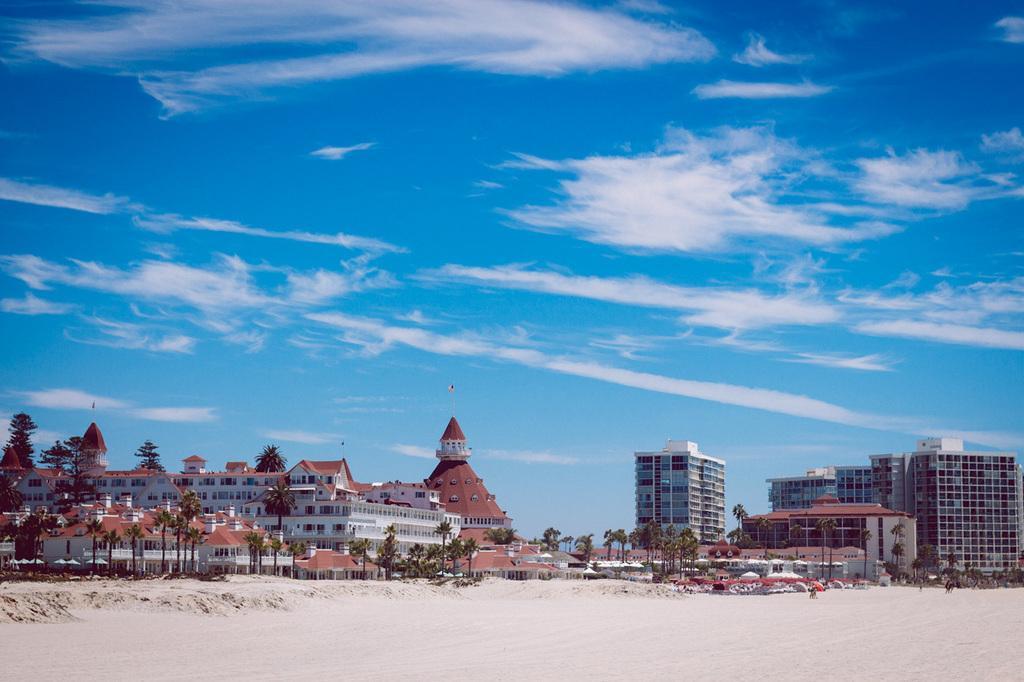Could you give a brief overview of what you see in this image? In this image I can see land in the front. There are trees and buildings at the back. There is sky at the top. 